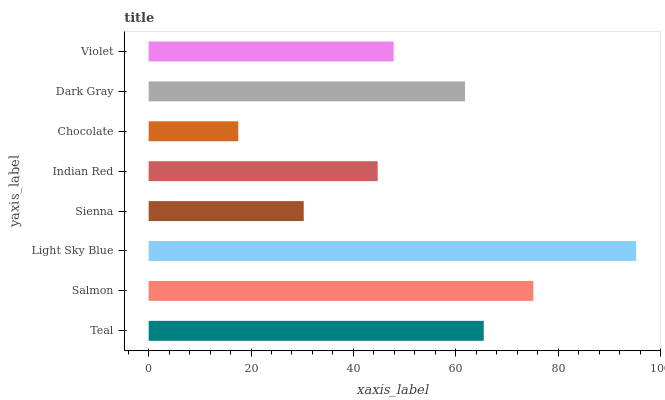Is Chocolate the minimum?
Answer yes or no. Yes. Is Light Sky Blue the maximum?
Answer yes or no. Yes. Is Salmon the minimum?
Answer yes or no. No. Is Salmon the maximum?
Answer yes or no. No. Is Salmon greater than Teal?
Answer yes or no. Yes. Is Teal less than Salmon?
Answer yes or no. Yes. Is Teal greater than Salmon?
Answer yes or no. No. Is Salmon less than Teal?
Answer yes or no. No. Is Dark Gray the high median?
Answer yes or no. Yes. Is Violet the low median?
Answer yes or no. Yes. Is Violet the high median?
Answer yes or no. No. Is Dark Gray the low median?
Answer yes or no. No. 